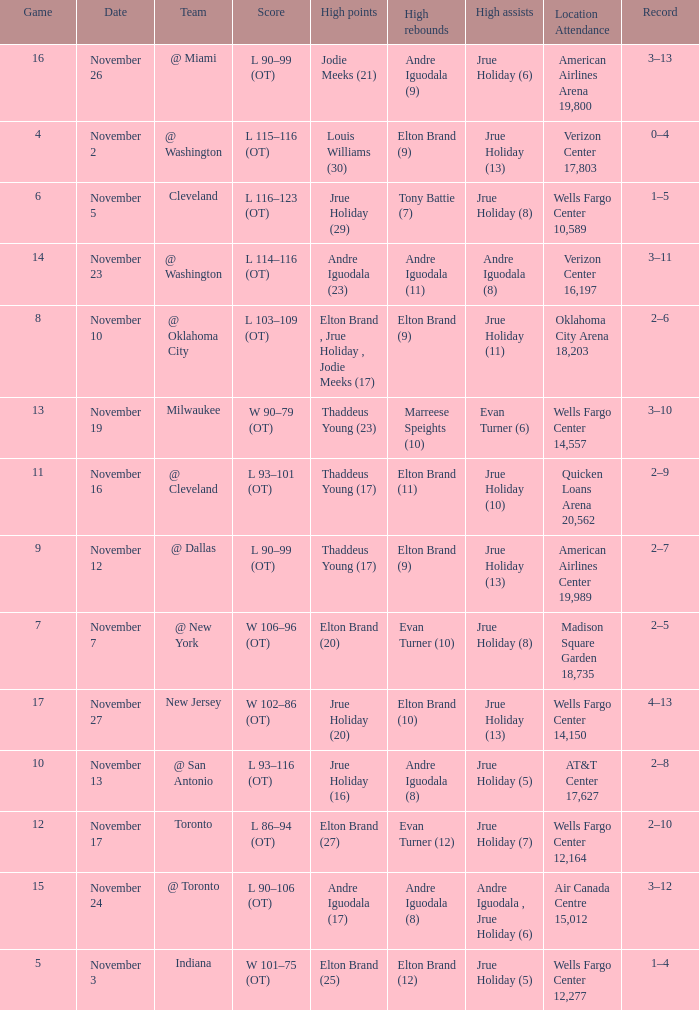What is the score for the game with the record of 3–12? L 90–106 (OT). 